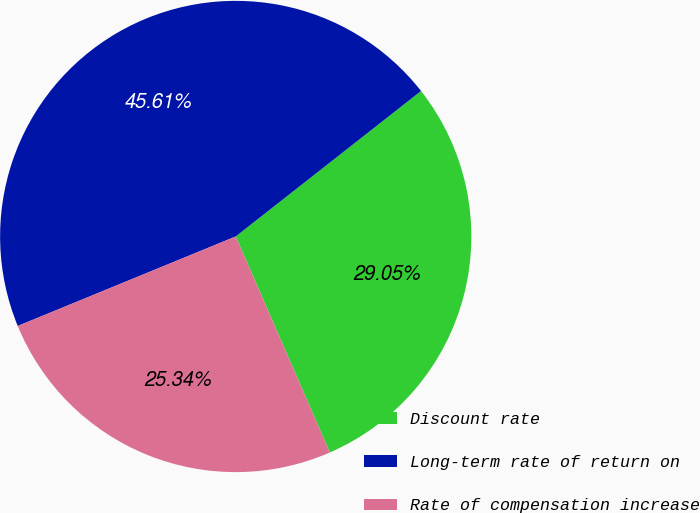Convert chart. <chart><loc_0><loc_0><loc_500><loc_500><pie_chart><fcel>Discount rate<fcel>Long-term rate of return on<fcel>Rate of compensation increase<nl><fcel>29.05%<fcel>45.61%<fcel>25.34%<nl></chart> 